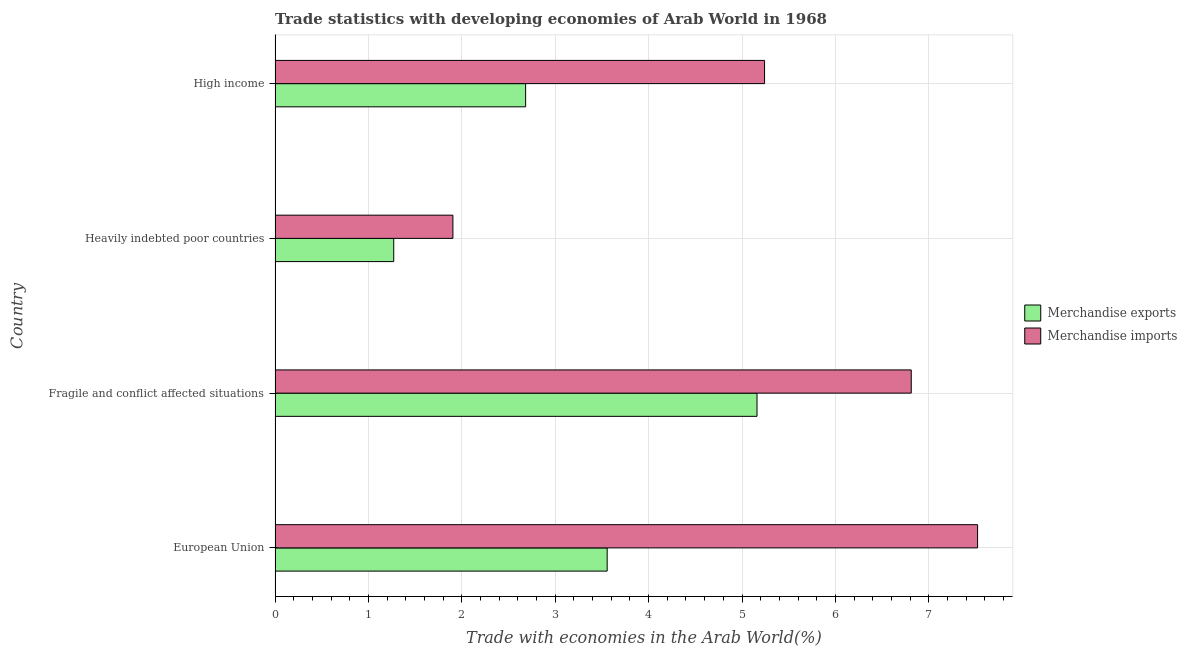How many different coloured bars are there?
Your response must be concise. 2. How many groups of bars are there?
Your answer should be compact. 4. Are the number of bars on each tick of the Y-axis equal?
Ensure brevity in your answer.  Yes. How many bars are there on the 1st tick from the top?
Provide a short and direct response. 2. What is the label of the 1st group of bars from the top?
Provide a succinct answer. High income. In how many cases, is the number of bars for a given country not equal to the number of legend labels?
Ensure brevity in your answer.  0. What is the merchandise exports in High income?
Your response must be concise. 2.68. Across all countries, what is the maximum merchandise exports?
Make the answer very short. 5.16. Across all countries, what is the minimum merchandise imports?
Ensure brevity in your answer.  1.9. In which country was the merchandise imports minimum?
Give a very brief answer. Heavily indebted poor countries. What is the total merchandise imports in the graph?
Provide a short and direct response. 21.48. What is the difference between the merchandise exports in Fragile and conflict affected situations and that in Heavily indebted poor countries?
Provide a short and direct response. 3.89. What is the difference between the merchandise imports in High income and the merchandise exports in Heavily indebted poor countries?
Provide a succinct answer. 3.97. What is the average merchandise exports per country?
Offer a very short reply. 3.17. What is the difference between the merchandise imports and merchandise exports in European Union?
Make the answer very short. 3.97. In how many countries, is the merchandise imports greater than 4.2 %?
Give a very brief answer. 3. Is the merchandise imports in Fragile and conflict affected situations less than that in High income?
Your answer should be very brief. No. Is the difference between the merchandise exports in European Union and Fragile and conflict affected situations greater than the difference between the merchandise imports in European Union and Fragile and conflict affected situations?
Offer a very short reply. No. What is the difference between the highest and the second highest merchandise exports?
Offer a terse response. 1.6. What is the difference between the highest and the lowest merchandise exports?
Offer a terse response. 3.89. Is the sum of the merchandise exports in Fragile and conflict affected situations and Heavily indebted poor countries greater than the maximum merchandise imports across all countries?
Give a very brief answer. No. Are all the bars in the graph horizontal?
Your response must be concise. Yes. How many countries are there in the graph?
Provide a succinct answer. 4. Does the graph contain any zero values?
Your response must be concise. No. What is the title of the graph?
Your response must be concise. Trade statistics with developing economies of Arab World in 1968. What is the label or title of the X-axis?
Offer a very short reply. Trade with economies in the Arab World(%). What is the label or title of the Y-axis?
Make the answer very short. Country. What is the Trade with economies in the Arab World(%) in Merchandise exports in European Union?
Make the answer very short. 3.56. What is the Trade with economies in the Arab World(%) in Merchandise imports in European Union?
Give a very brief answer. 7.52. What is the Trade with economies in the Arab World(%) of Merchandise exports in Fragile and conflict affected situations?
Provide a short and direct response. 5.16. What is the Trade with economies in the Arab World(%) in Merchandise imports in Fragile and conflict affected situations?
Make the answer very short. 6.81. What is the Trade with economies in the Arab World(%) of Merchandise exports in Heavily indebted poor countries?
Keep it short and to the point. 1.27. What is the Trade with economies in the Arab World(%) of Merchandise imports in Heavily indebted poor countries?
Your answer should be very brief. 1.9. What is the Trade with economies in the Arab World(%) of Merchandise exports in High income?
Keep it short and to the point. 2.68. What is the Trade with economies in the Arab World(%) of Merchandise imports in High income?
Your answer should be compact. 5.24. Across all countries, what is the maximum Trade with economies in the Arab World(%) of Merchandise exports?
Your answer should be compact. 5.16. Across all countries, what is the maximum Trade with economies in the Arab World(%) of Merchandise imports?
Offer a terse response. 7.52. Across all countries, what is the minimum Trade with economies in the Arab World(%) in Merchandise exports?
Offer a terse response. 1.27. Across all countries, what is the minimum Trade with economies in the Arab World(%) in Merchandise imports?
Your answer should be compact. 1.9. What is the total Trade with economies in the Arab World(%) in Merchandise exports in the graph?
Keep it short and to the point. 12.67. What is the total Trade with economies in the Arab World(%) of Merchandise imports in the graph?
Offer a terse response. 21.48. What is the difference between the Trade with economies in the Arab World(%) in Merchandise exports in European Union and that in Fragile and conflict affected situations?
Your response must be concise. -1.6. What is the difference between the Trade with economies in the Arab World(%) of Merchandise imports in European Union and that in Fragile and conflict affected situations?
Your response must be concise. 0.71. What is the difference between the Trade with economies in the Arab World(%) in Merchandise exports in European Union and that in Heavily indebted poor countries?
Offer a very short reply. 2.29. What is the difference between the Trade with economies in the Arab World(%) of Merchandise imports in European Union and that in Heavily indebted poor countries?
Offer a very short reply. 5.62. What is the difference between the Trade with economies in the Arab World(%) of Merchandise exports in European Union and that in High income?
Your response must be concise. 0.87. What is the difference between the Trade with economies in the Arab World(%) of Merchandise imports in European Union and that in High income?
Make the answer very short. 2.28. What is the difference between the Trade with economies in the Arab World(%) of Merchandise exports in Fragile and conflict affected situations and that in Heavily indebted poor countries?
Your answer should be compact. 3.89. What is the difference between the Trade with economies in the Arab World(%) of Merchandise imports in Fragile and conflict affected situations and that in Heavily indebted poor countries?
Provide a short and direct response. 4.91. What is the difference between the Trade with economies in the Arab World(%) of Merchandise exports in Fragile and conflict affected situations and that in High income?
Offer a terse response. 2.48. What is the difference between the Trade with economies in the Arab World(%) of Merchandise imports in Fragile and conflict affected situations and that in High income?
Offer a terse response. 1.57. What is the difference between the Trade with economies in the Arab World(%) of Merchandise exports in Heavily indebted poor countries and that in High income?
Provide a short and direct response. -1.41. What is the difference between the Trade with economies in the Arab World(%) of Merchandise imports in Heavily indebted poor countries and that in High income?
Your answer should be compact. -3.34. What is the difference between the Trade with economies in the Arab World(%) of Merchandise exports in European Union and the Trade with economies in the Arab World(%) of Merchandise imports in Fragile and conflict affected situations?
Your answer should be compact. -3.26. What is the difference between the Trade with economies in the Arab World(%) in Merchandise exports in European Union and the Trade with economies in the Arab World(%) in Merchandise imports in Heavily indebted poor countries?
Provide a succinct answer. 1.65. What is the difference between the Trade with economies in the Arab World(%) in Merchandise exports in European Union and the Trade with economies in the Arab World(%) in Merchandise imports in High income?
Your answer should be very brief. -1.69. What is the difference between the Trade with economies in the Arab World(%) of Merchandise exports in Fragile and conflict affected situations and the Trade with economies in the Arab World(%) of Merchandise imports in Heavily indebted poor countries?
Give a very brief answer. 3.26. What is the difference between the Trade with economies in the Arab World(%) of Merchandise exports in Fragile and conflict affected situations and the Trade with economies in the Arab World(%) of Merchandise imports in High income?
Your answer should be compact. -0.08. What is the difference between the Trade with economies in the Arab World(%) in Merchandise exports in Heavily indebted poor countries and the Trade with economies in the Arab World(%) in Merchandise imports in High income?
Offer a very short reply. -3.97. What is the average Trade with economies in the Arab World(%) of Merchandise exports per country?
Keep it short and to the point. 3.17. What is the average Trade with economies in the Arab World(%) in Merchandise imports per country?
Offer a very short reply. 5.37. What is the difference between the Trade with economies in the Arab World(%) in Merchandise exports and Trade with economies in the Arab World(%) in Merchandise imports in European Union?
Your response must be concise. -3.97. What is the difference between the Trade with economies in the Arab World(%) of Merchandise exports and Trade with economies in the Arab World(%) of Merchandise imports in Fragile and conflict affected situations?
Give a very brief answer. -1.65. What is the difference between the Trade with economies in the Arab World(%) of Merchandise exports and Trade with economies in the Arab World(%) of Merchandise imports in Heavily indebted poor countries?
Make the answer very short. -0.63. What is the difference between the Trade with economies in the Arab World(%) of Merchandise exports and Trade with economies in the Arab World(%) of Merchandise imports in High income?
Offer a very short reply. -2.56. What is the ratio of the Trade with economies in the Arab World(%) of Merchandise exports in European Union to that in Fragile and conflict affected situations?
Provide a short and direct response. 0.69. What is the ratio of the Trade with economies in the Arab World(%) of Merchandise imports in European Union to that in Fragile and conflict affected situations?
Your response must be concise. 1.1. What is the ratio of the Trade with economies in the Arab World(%) in Merchandise exports in European Union to that in Heavily indebted poor countries?
Keep it short and to the point. 2.8. What is the ratio of the Trade with economies in the Arab World(%) of Merchandise imports in European Union to that in Heavily indebted poor countries?
Offer a very short reply. 3.95. What is the ratio of the Trade with economies in the Arab World(%) of Merchandise exports in European Union to that in High income?
Ensure brevity in your answer.  1.33. What is the ratio of the Trade with economies in the Arab World(%) in Merchandise imports in European Union to that in High income?
Provide a short and direct response. 1.44. What is the ratio of the Trade with economies in the Arab World(%) of Merchandise exports in Fragile and conflict affected situations to that in Heavily indebted poor countries?
Keep it short and to the point. 4.06. What is the ratio of the Trade with economies in the Arab World(%) in Merchandise imports in Fragile and conflict affected situations to that in Heavily indebted poor countries?
Your answer should be compact. 3.58. What is the ratio of the Trade with economies in the Arab World(%) in Merchandise exports in Fragile and conflict affected situations to that in High income?
Ensure brevity in your answer.  1.92. What is the ratio of the Trade with economies in the Arab World(%) of Merchandise imports in Fragile and conflict affected situations to that in High income?
Give a very brief answer. 1.3. What is the ratio of the Trade with economies in the Arab World(%) of Merchandise exports in Heavily indebted poor countries to that in High income?
Provide a short and direct response. 0.47. What is the ratio of the Trade with economies in the Arab World(%) of Merchandise imports in Heavily indebted poor countries to that in High income?
Your response must be concise. 0.36. What is the difference between the highest and the second highest Trade with economies in the Arab World(%) in Merchandise exports?
Offer a very short reply. 1.6. What is the difference between the highest and the second highest Trade with economies in the Arab World(%) of Merchandise imports?
Your answer should be compact. 0.71. What is the difference between the highest and the lowest Trade with economies in the Arab World(%) in Merchandise exports?
Ensure brevity in your answer.  3.89. What is the difference between the highest and the lowest Trade with economies in the Arab World(%) of Merchandise imports?
Provide a succinct answer. 5.62. 